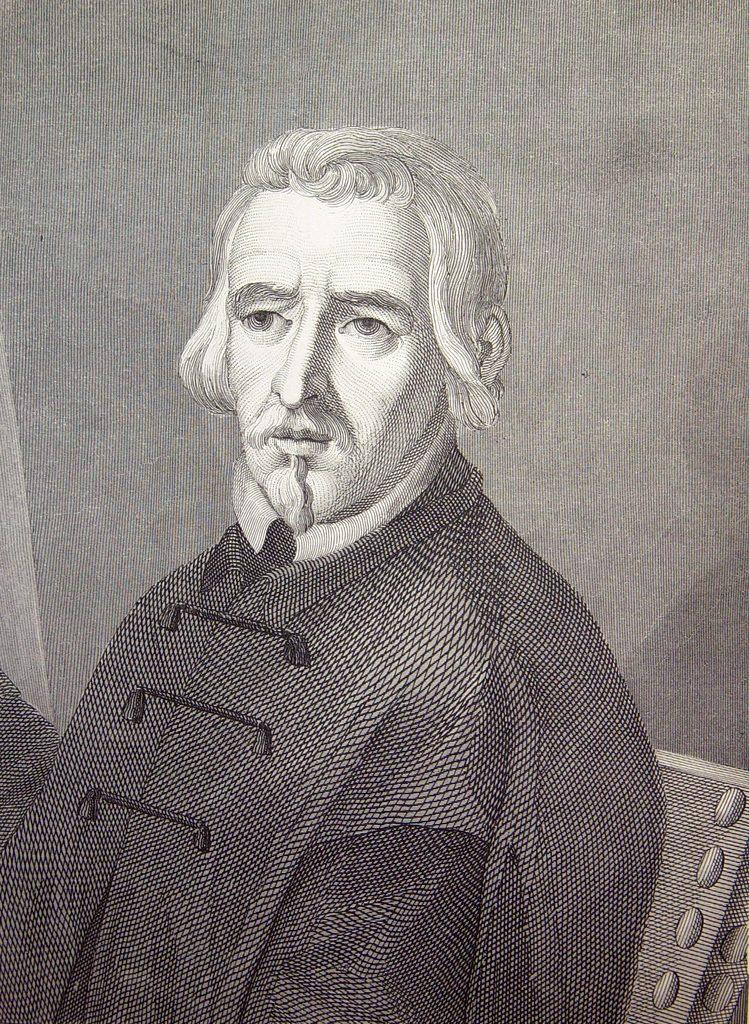What type of artwork is shown in the image? The image is a sketch. What is the main subject of the sketch? The sketch depicts a person. What can be seen in the background of the sketch? There is a wall in the background of the sketch. Is the person in the sketch sinking in quicksand? There is no quicksand present in the sketch, and the person is not sinking. What type of toothbrush is the person using in the sketch? There is no toothbrush present in the sketch, as it is a drawing of a person and not a scene involving personal hygiene. 